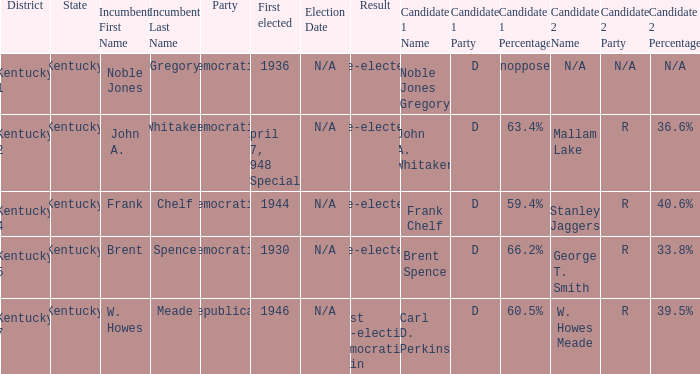Who were the candidates in the Kentucky 4 voting district? Frank Chelf (D) 59.4% Stanley Jaggers (R) 40.6%. Help me parse the entirety of this table. {'header': ['District', 'State', 'Incumbent First Name', 'Incumbent Last Name', 'Party', 'First elected', 'Election Date', 'Result', 'Candidate 1 Name', 'Candidate 1 Party', 'Candidate 1 Percentage', 'Candidate 2 Name', 'Candidate 2 Party', 'Candidate 2 Percentage'], 'rows': [['Kentucky 1', 'Kentucky', 'Noble Jones', 'Gregory', 'Democratic', '1936', 'N/A', 'Re-elected', 'Noble Jones Gregory', 'D', 'Unopposed', 'N/A', 'N/A', 'N/A'], ['Kentucky 2', 'Kentucky', 'John A.', 'Whitaker', 'Democratic', 'April 17, 1948 (Special)', 'N/A', 'Re-elected', 'John A. Whitaker', 'D', '63.4%', 'Mallam Lake', 'R', '36.6%'], ['Kentucky 4', 'Kentucky', 'Frank', 'Chelf', 'Democratic', '1944', 'N/A', 'Re-elected', 'Frank Chelf', 'D', '59.4%', 'Stanley Jaggers', 'R', '40.6%'], ['Kentucky 5', 'Kentucky', 'Brent', 'Spence', 'Democratic', '1930', 'N/A', 'Re-elected', 'Brent Spence', 'D', '66.2%', 'George T. Smith', 'R', '33.8%'], ['Kentucky 7', 'Kentucky', 'W. Howes', 'Meade', 'Republican', '1946', 'N/A', 'Lost re-election Democratic gain', 'Carl D. Perkins', 'D', '60.5%', 'W. Howes Meade', 'R', '39.5%']]} 